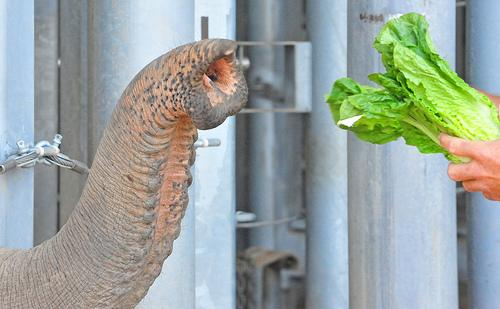Identify the items you would notice in the background if you observed the scene in person. In the background, I would notice grey building parts, metal cables on the elephant cage, and thick metal poles. Identify the primary action between the person and the elephant in the image. A person is holding lettuce toward the elephant's trunk, attempting to feed it. Detail the appearance of the elephant's trunk in the image. The elephant's trunk is wrinkled, grey and pink, and has some orange and black spots on it. Describe the environment in which the elephant is located. The elephant is in front of a metal wall and a metal cage with cables and hooks on the wall. If you were to create an advertisement for lettuce using this image, what tagline would you use? "Romaine lettuce: so fresh and delicious, even elephants can't resist!" For the visual entailment task, determine the connection between the elephant's trunk and the lettuce. The elephant's trunk is reaching out to grab the lettuce being held by a person. In the multi-choice VQA task, select the best description for the person's action in the image. The person is holding out green lettuce leaves toward the elephant's trunk. What type of vegetable is the person offering to the elephant, and what color is it? The person is offering bright green romaine lettuce to the elephant. 